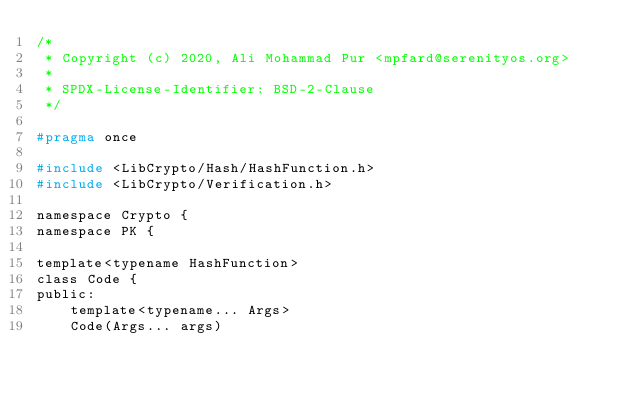<code> <loc_0><loc_0><loc_500><loc_500><_C_>/*
 * Copyright (c) 2020, Ali Mohammad Pur <mpfard@serenityos.org>
 *
 * SPDX-License-Identifier: BSD-2-Clause
 */

#pragma once

#include <LibCrypto/Hash/HashFunction.h>
#include <LibCrypto/Verification.h>

namespace Crypto {
namespace PK {

template<typename HashFunction>
class Code {
public:
    template<typename... Args>
    Code(Args... args)</code> 